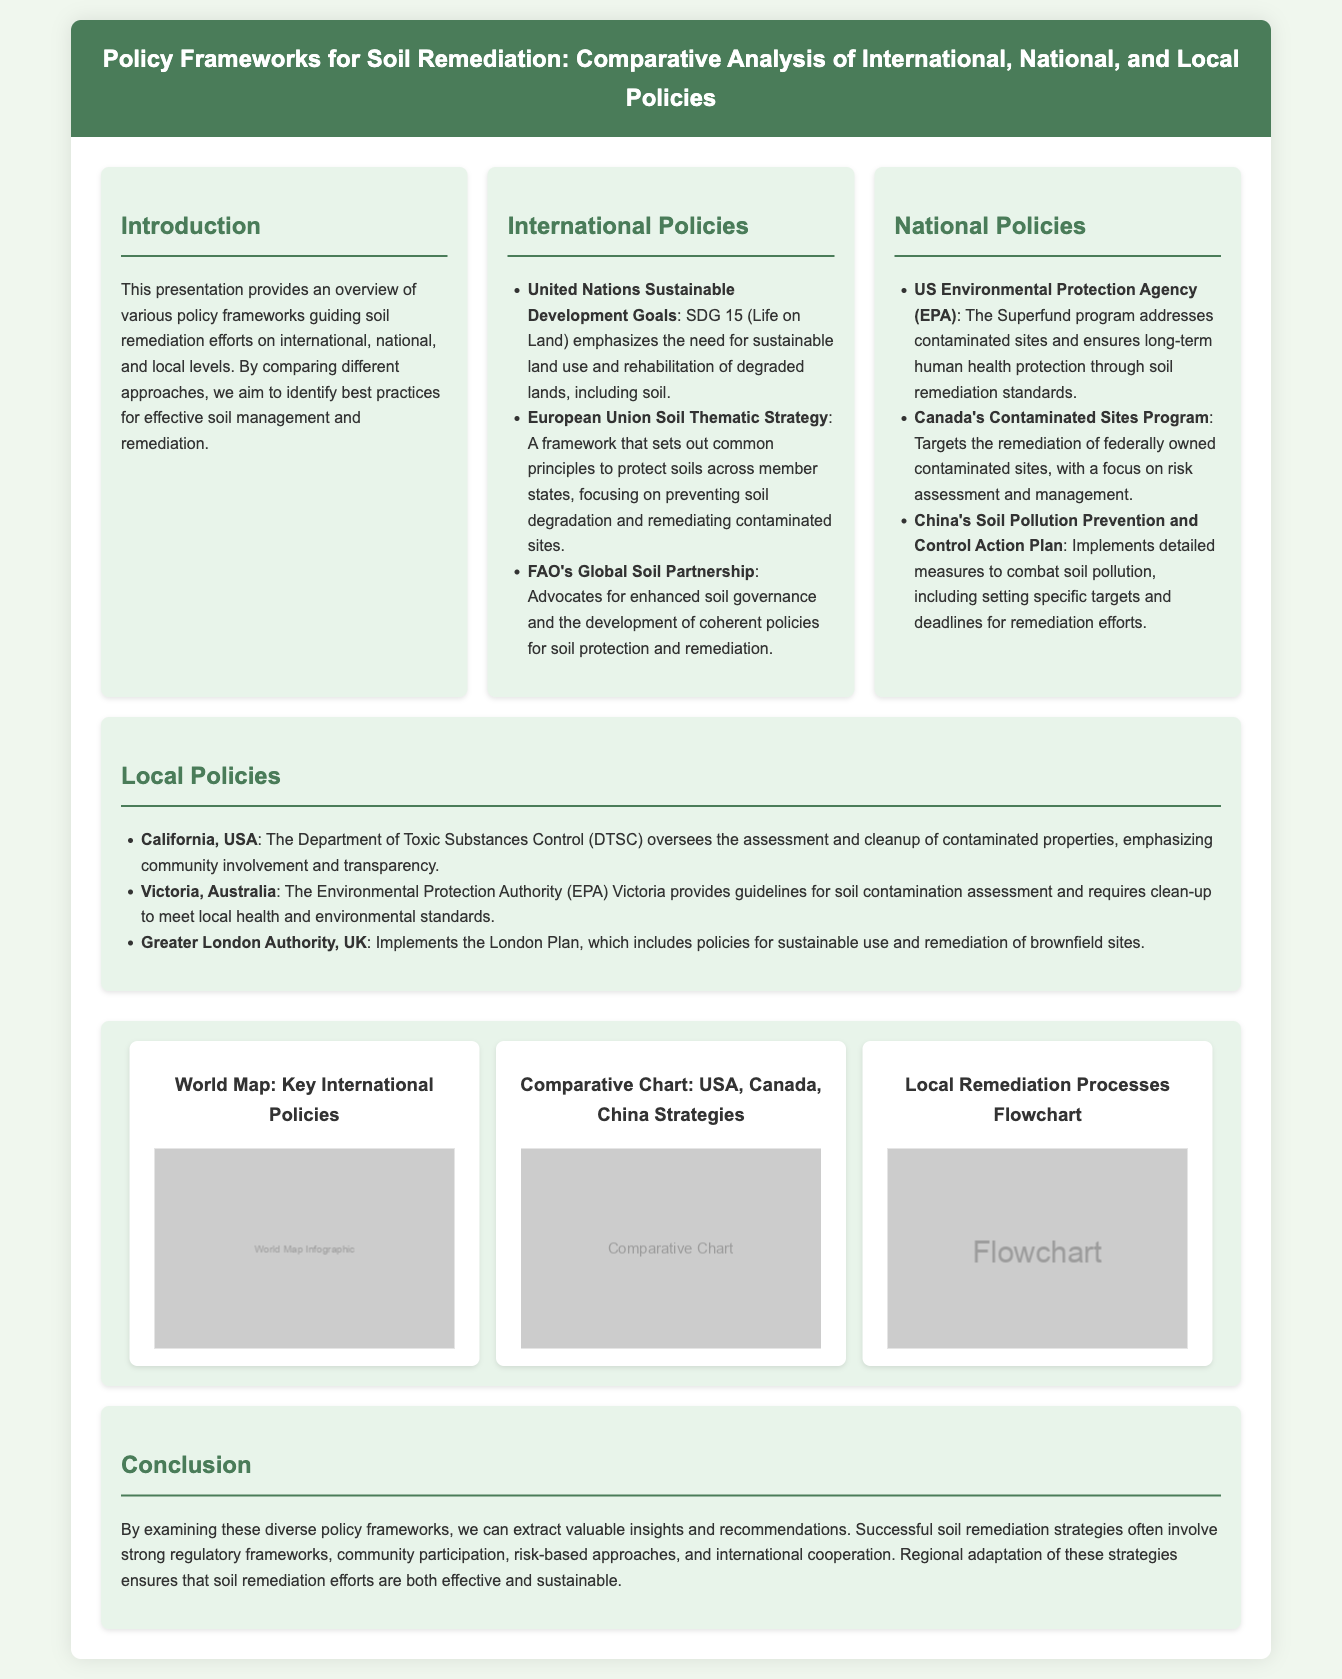what is the title of the presentation? The title of the presentation is at the top of the document, presenting the main topic discussed.
Answer: Policy Frameworks for Soil Remediation: Comparative Analysis of International, National, and Local Policies which United Nations initiative addresses sustainable land use? This information is found under the section on International Policies, referring specifically to a key initiative.
Answer: United Nations Sustainable Development Goals what is a focus of the European Union Soil Thematic Strategy? The information is provided in the context of preventative measures related to soil management.
Answer: Preventing soil degradation which program in the USA deals with contaminated sites? The answer is related to national policies specific to the country and addresses soil remediation efforts.
Answer: Superfund program what is emphasized in California's local policies regarding contaminated properties? This question explores the nature of local policies specific to community involvement in remediation processes.
Answer: Community involvement how does the FAO contribute to soil protection? This question delves into international policies promoting enhanced governance and policy development for soil.
Answer: Advocates for enhanced soil governance what does the comparative chart infographic illustrate? This is based on the visual representation included in the document, pertaining to specific national strategies.
Answer: USA, Canada, China Strategies what is the aim of the conclusion section? This question relates to the overall intent and recommendations provided in the conclusion of the document.
Answer: Extract valuable insights and recommendations 